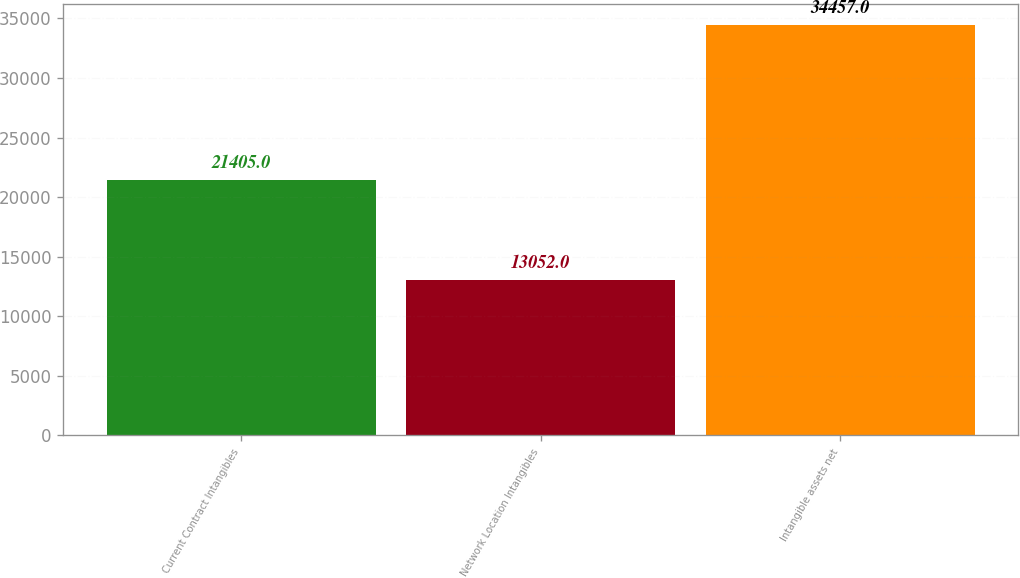<chart> <loc_0><loc_0><loc_500><loc_500><bar_chart><fcel>Current Contract Intangibles<fcel>Network Location Intangibles<fcel>Intangible assets net<nl><fcel>21405<fcel>13052<fcel>34457<nl></chart> 